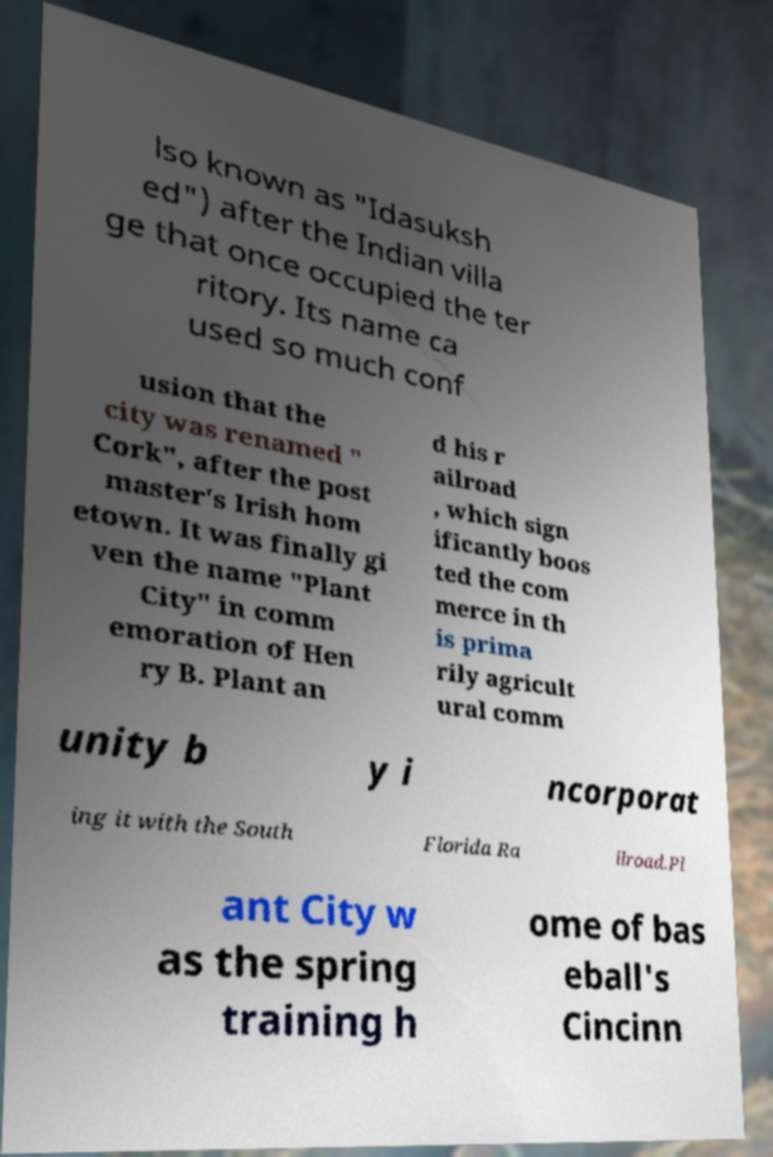Could you assist in decoding the text presented in this image and type it out clearly? lso known as "Idasuksh ed") after the Indian villa ge that once occupied the ter ritory. Its name ca used so much conf usion that the city was renamed " Cork", after the post master's Irish hom etown. It was finally gi ven the name "Plant City" in comm emoration of Hen ry B. Plant an d his r ailroad , which sign ificantly boos ted the com merce in th is prima rily agricult ural comm unity b y i ncorporat ing it with the South Florida Ra ilroad.Pl ant City w as the spring training h ome of bas eball's Cincinn 